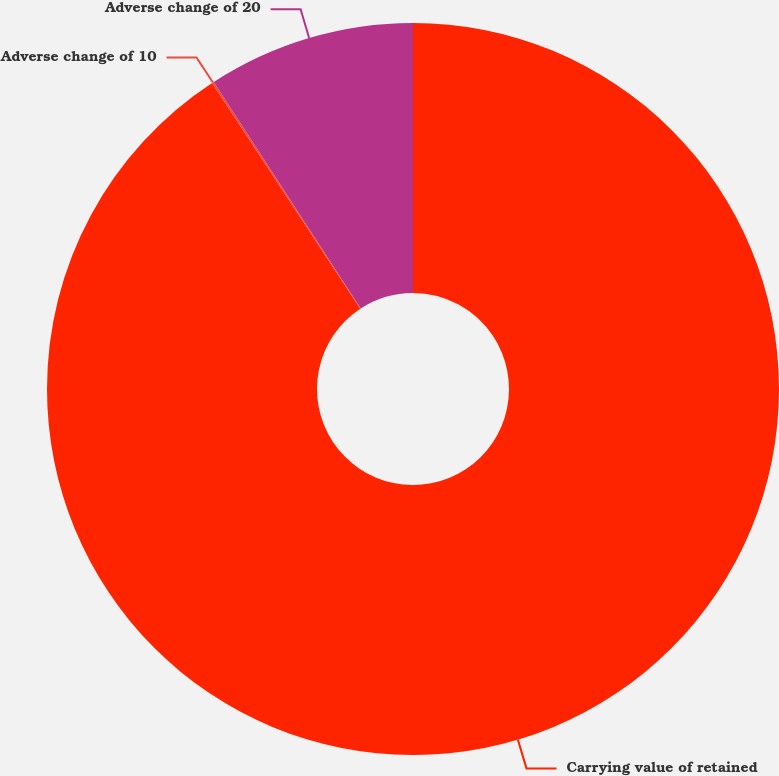Convert chart. <chart><loc_0><loc_0><loc_500><loc_500><pie_chart><fcel>Carrying value of retained<fcel>Adverse change of 10<fcel>Adverse change of 20<nl><fcel>90.75%<fcel>0.09%<fcel>9.16%<nl></chart> 